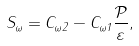<formula> <loc_0><loc_0><loc_500><loc_500>S _ { \omega } = C _ { \omega 2 } - C _ { \omega 1 } \frac { \mathcal { P } } { \varepsilon } ,</formula> 